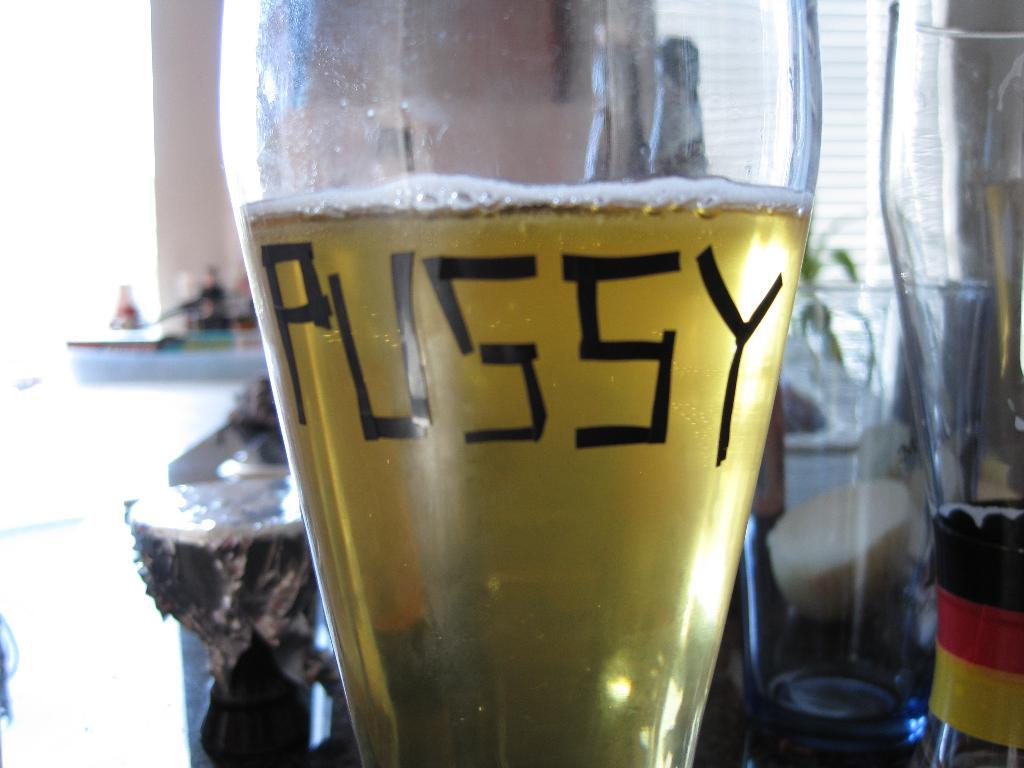<image>
Relay a brief, clear account of the picture shown. A glass of beer with a word on the front that could refer to a female cat 